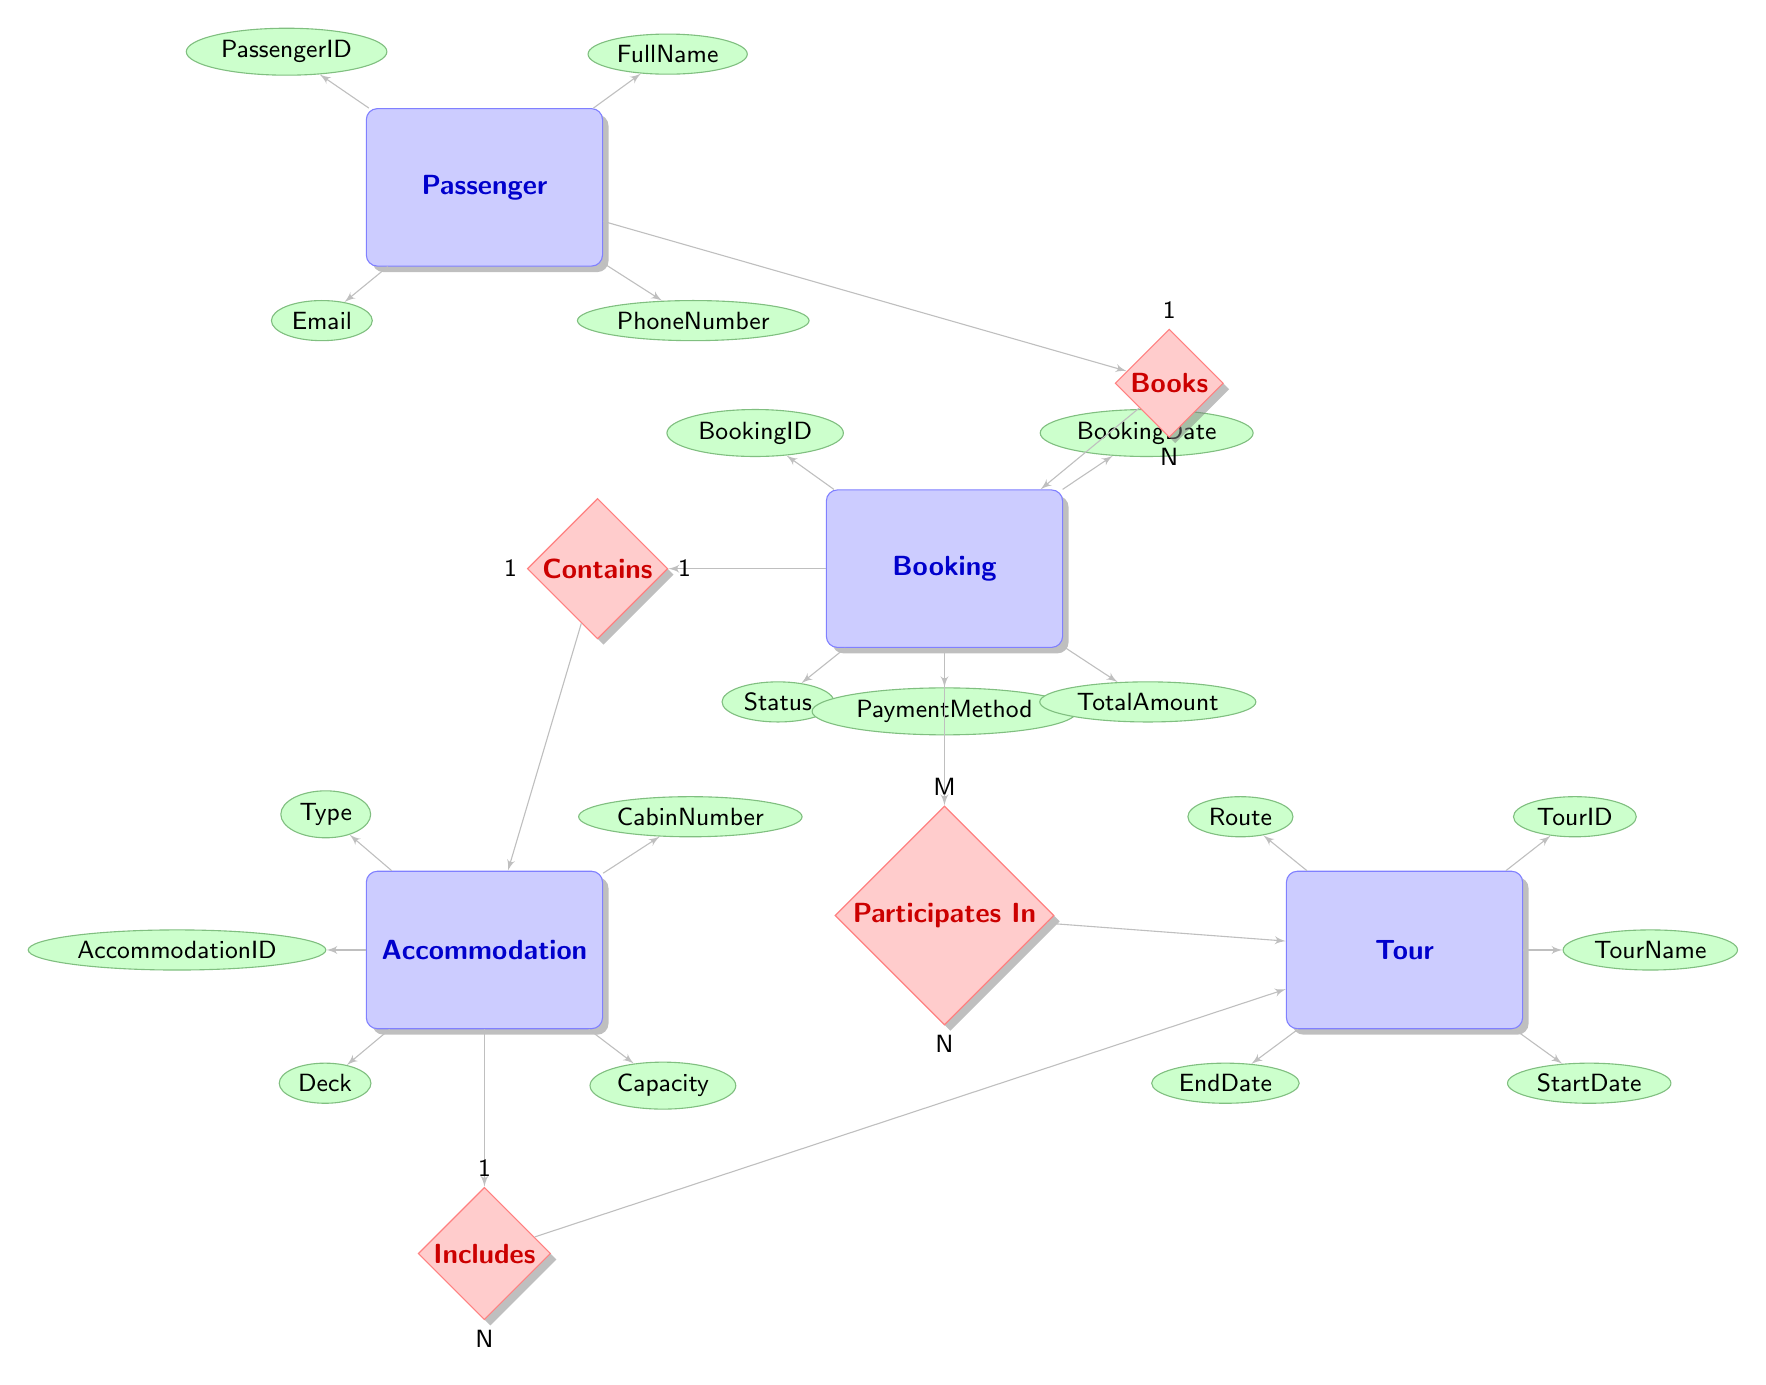what is the number of entities in the diagram? There are four entities in the diagram: Passenger, Booking, Accommodation, and Tour. To find the number of entities, we simply count them in the "entities" section of the diagram.
Answer: 4 which entity has the attribute 'FullName'? The 'FullName' attribute belongs to the Passenger entity. By reviewing the attributes listed under each entity, we can identify that 'FullName' is associated with Passenger.
Answer: Passenger how many attributes does the Booking entity have? The Booking entity has five attributes: BookingID, BookingDate, Status, PaymentMethod, and TotalAmount. By counting these listed attributes associated with the Booking entity, we determine their number.
Answer: 5 what is the relationship type between Booking and Accommodation? The relationship type between Booking and Accommodation is one-to-one. This is indicated by the cardinality notation next to the "Contains" relationship that connects these two entities.
Answer: one-to-one how many tours can a single Booking participate in? A single Booking can participate in many Tours. This is determined from the "Participates In" relationship, which has 'M' (many) on the Booking side, indicating that one booking may correspond to multiple tours.
Answer: many what is the maximum capacity of an Accommodation? The maximum capacity is determined by the Capacity attribute of the Accommodation entity. Since each Accommodation has its specific capacity defined, we find this attribute under the Accommodation entity.
Answer: Capacity which entity is linked to the Tours through the Includes relationship? The Accommodation entity is linked to Tours through the Includes relationship. This is evident from the relationship labeled "Includes," which connects the Accommodation entity to the Tour entity in the diagram.
Answer: Accommodation how is a Passenger connected to Booking? A Passenger is connected to Booking through the "Books" relationship, which indicates that each Passenger can have multiple bookings, represented as one-to-many cardinality in the diagram.
Answer: Books what does the PaymentMethod attribute describe? The PaymentMethod attribute describes the method used for payment in the Booking entity. This attribute provides information relevant to the booking transaction and is linked to the Booking entity specifically.
Answer: PaymentMethod 